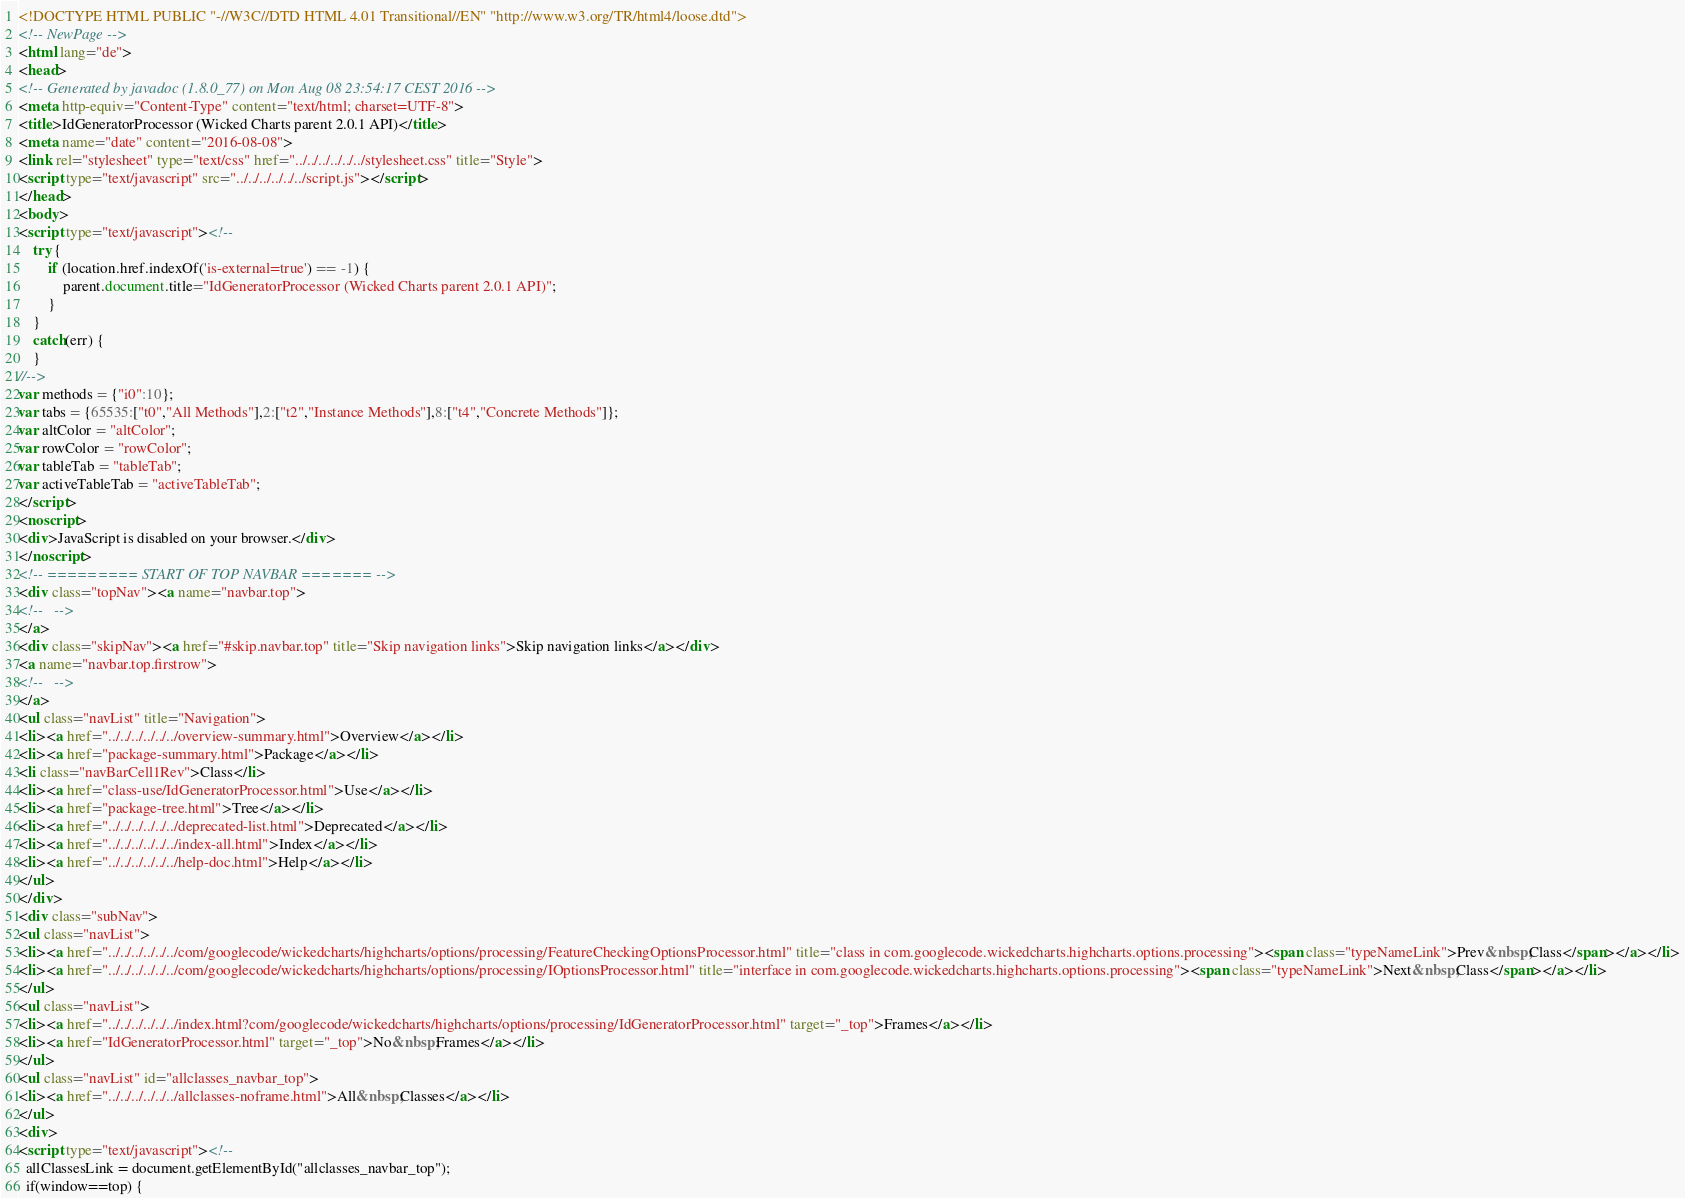<code> <loc_0><loc_0><loc_500><loc_500><_HTML_><!DOCTYPE HTML PUBLIC "-//W3C//DTD HTML 4.01 Transitional//EN" "http://www.w3.org/TR/html4/loose.dtd">
<!-- NewPage -->
<html lang="de">
<head>
<!-- Generated by javadoc (1.8.0_77) on Mon Aug 08 23:54:17 CEST 2016 -->
<meta http-equiv="Content-Type" content="text/html; charset=UTF-8">
<title>IdGeneratorProcessor (Wicked Charts parent 2.0.1 API)</title>
<meta name="date" content="2016-08-08">
<link rel="stylesheet" type="text/css" href="../../../../../../stylesheet.css" title="Style">
<script type="text/javascript" src="../../../../../../script.js"></script>
</head>
<body>
<script type="text/javascript"><!--
    try {
        if (location.href.indexOf('is-external=true') == -1) {
            parent.document.title="IdGeneratorProcessor (Wicked Charts parent 2.0.1 API)";
        }
    }
    catch(err) {
    }
//-->
var methods = {"i0":10};
var tabs = {65535:["t0","All Methods"],2:["t2","Instance Methods"],8:["t4","Concrete Methods"]};
var altColor = "altColor";
var rowColor = "rowColor";
var tableTab = "tableTab";
var activeTableTab = "activeTableTab";
</script>
<noscript>
<div>JavaScript is disabled on your browser.</div>
</noscript>
<!-- ========= START OF TOP NAVBAR ======= -->
<div class="topNav"><a name="navbar.top">
<!--   -->
</a>
<div class="skipNav"><a href="#skip.navbar.top" title="Skip navigation links">Skip navigation links</a></div>
<a name="navbar.top.firstrow">
<!--   -->
</a>
<ul class="navList" title="Navigation">
<li><a href="../../../../../../overview-summary.html">Overview</a></li>
<li><a href="package-summary.html">Package</a></li>
<li class="navBarCell1Rev">Class</li>
<li><a href="class-use/IdGeneratorProcessor.html">Use</a></li>
<li><a href="package-tree.html">Tree</a></li>
<li><a href="../../../../../../deprecated-list.html">Deprecated</a></li>
<li><a href="../../../../../../index-all.html">Index</a></li>
<li><a href="../../../../../../help-doc.html">Help</a></li>
</ul>
</div>
<div class="subNav">
<ul class="navList">
<li><a href="../../../../../../com/googlecode/wickedcharts/highcharts/options/processing/FeatureCheckingOptionsProcessor.html" title="class in com.googlecode.wickedcharts.highcharts.options.processing"><span class="typeNameLink">Prev&nbsp;Class</span></a></li>
<li><a href="../../../../../../com/googlecode/wickedcharts/highcharts/options/processing/IOptionsProcessor.html" title="interface in com.googlecode.wickedcharts.highcharts.options.processing"><span class="typeNameLink">Next&nbsp;Class</span></a></li>
</ul>
<ul class="navList">
<li><a href="../../../../../../index.html?com/googlecode/wickedcharts/highcharts/options/processing/IdGeneratorProcessor.html" target="_top">Frames</a></li>
<li><a href="IdGeneratorProcessor.html" target="_top">No&nbsp;Frames</a></li>
</ul>
<ul class="navList" id="allclasses_navbar_top">
<li><a href="../../../../../../allclasses-noframe.html">All&nbsp;Classes</a></li>
</ul>
<div>
<script type="text/javascript"><!--
  allClassesLink = document.getElementById("allclasses_navbar_top");
  if(window==top) {</code> 